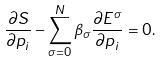Convert formula to latex. <formula><loc_0><loc_0><loc_500><loc_500>\frac { \partial S } { \partial p _ { i } } - \sum _ { \sigma = 0 } ^ { N } \beta _ { \sigma } \frac { \partial E ^ { \sigma } } { \partial p _ { i } } = 0 .</formula> 